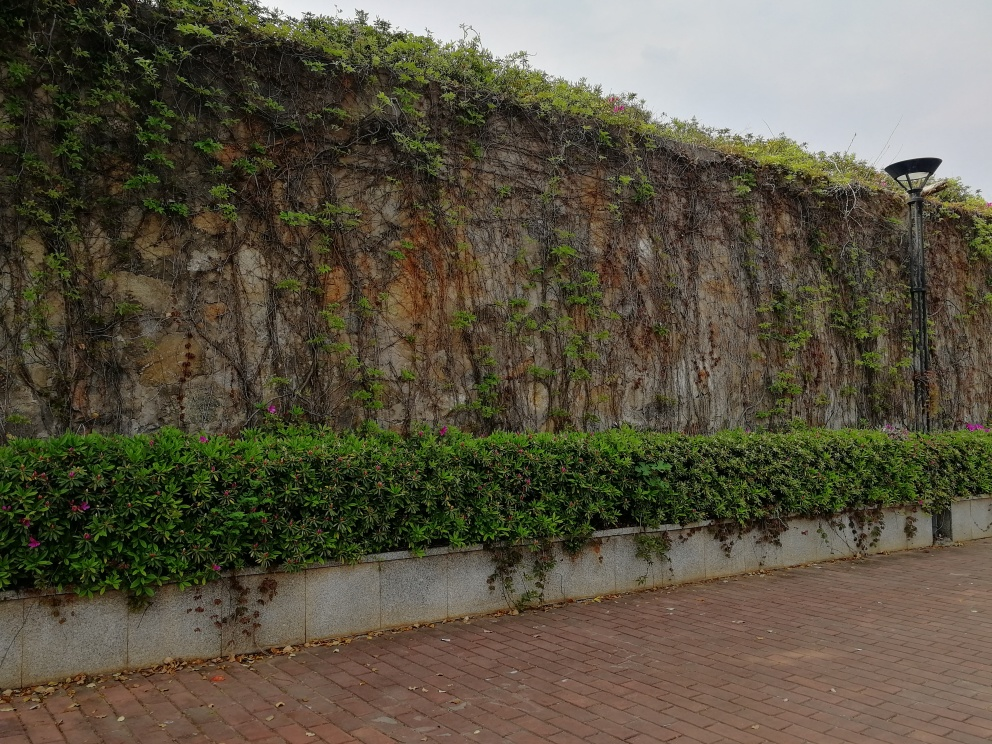What time of day does it appear to be in the image? Based on the lighting and shadows in the image, it seems to be during the daytime, possibly late afternoon, as there are soft shadows and the sky is overcast, diffusing the sunlight. 